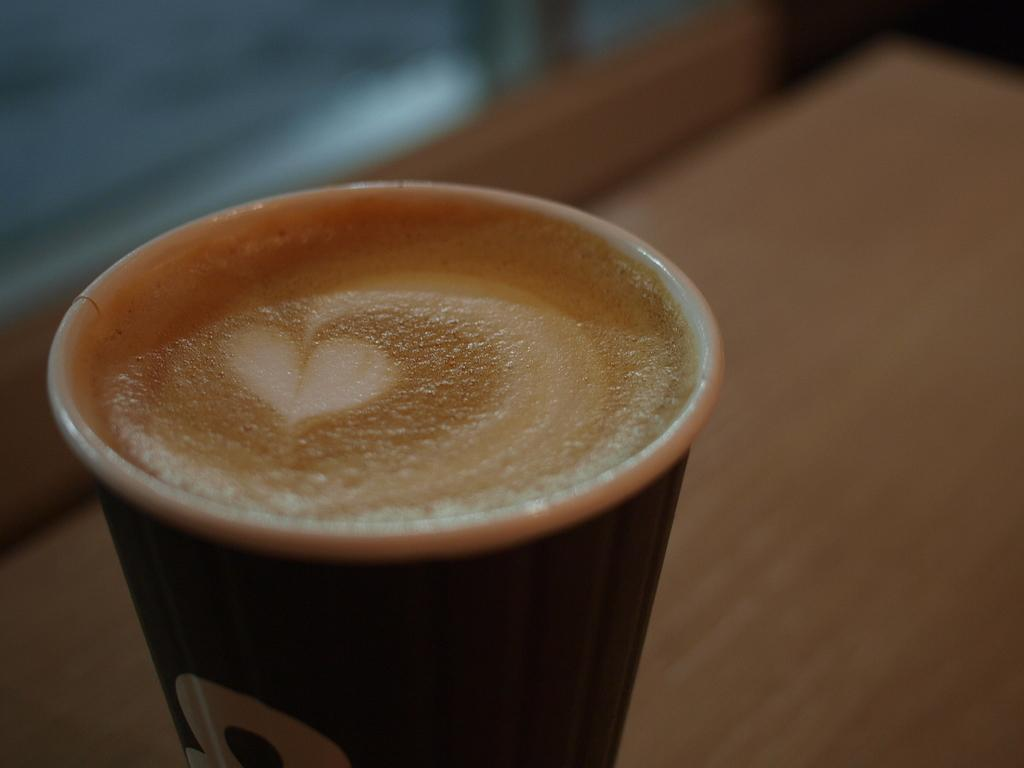What piece of furniture is present in the image? There is a table in the image. What is on the table in the image? There is a cup of coffee on the table. Can you describe the background of the image? The background of the image is blurry. What type of hair product is visible on the table in the image? There is no hair product visible on the table in the image; it only contains a cup of coffee. 